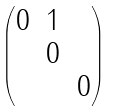Convert formula to latex. <formula><loc_0><loc_0><loc_500><loc_500>\begin{pmatrix} 0 & 1 & \\ & 0 & \\ & & 0 \end{pmatrix}</formula> 